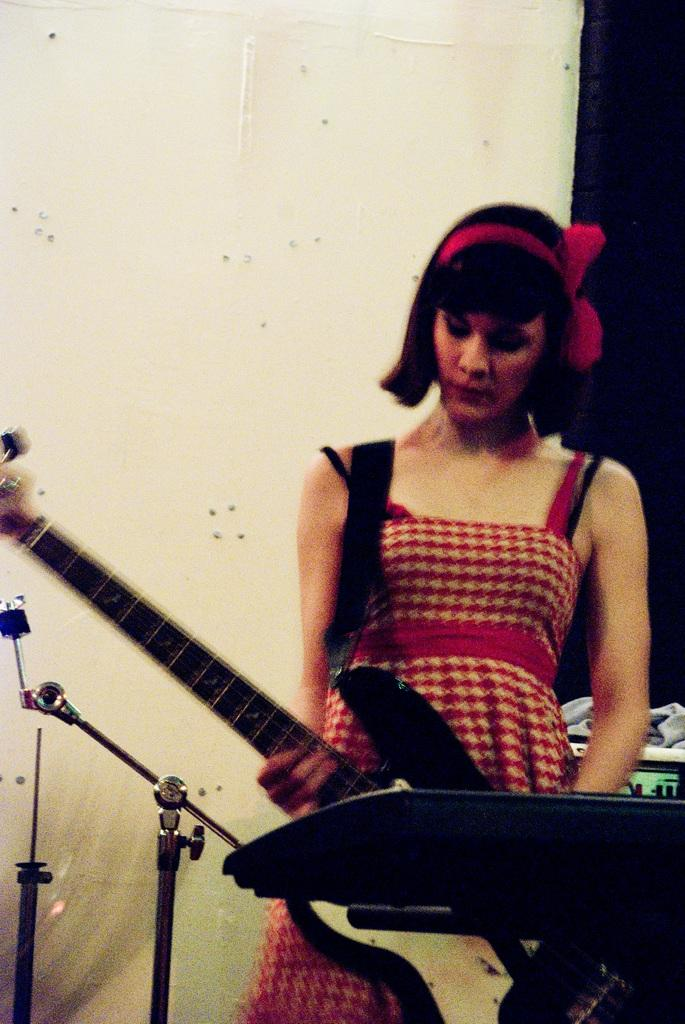What is the main subject of the image? There is a person standing in the image. What is the person wearing? The person is wearing a red dress. What is the person holding in her hand? The person is holding a guitar in her hand. What type of prose is being recited by the person in the image? There is no indication in the image that the person is reciting any prose. 